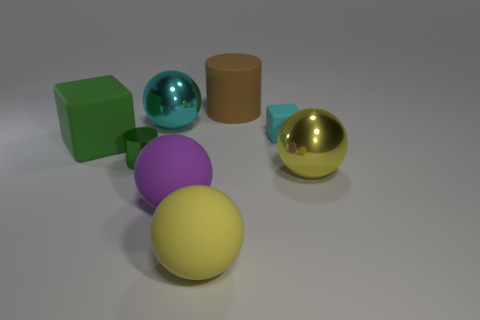Is the color of the rubber cylinder the same as the small cylinder?
Keep it short and to the point. No. Does the tiny cylinder have the same material as the tiny block?
Offer a terse response. No. Is there anything else that is the same color as the large cylinder?
Give a very brief answer. No. The brown object is what shape?
Provide a succinct answer. Cylinder. There is a shiny object that is left of the small cyan thing and in front of the tiny matte object; what size is it?
Offer a terse response. Small. There is a big yellow sphere to the right of the brown cylinder; what material is it?
Offer a terse response. Metal. There is a small matte thing; is its color the same as the big shiny thing behind the small metallic thing?
Offer a very short reply. Yes. How many things are either cyan things that are to the left of the tiny cyan matte block or green things to the right of the green rubber cube?
Ensure brevity in your answer.  2. There is a object that is both behind the cyan matte thing and in front of the brown thing; what is its color?
Your answer should be compact. Cyan. Are there more cubes than large matte objects?
Your answer should be compact. No. 